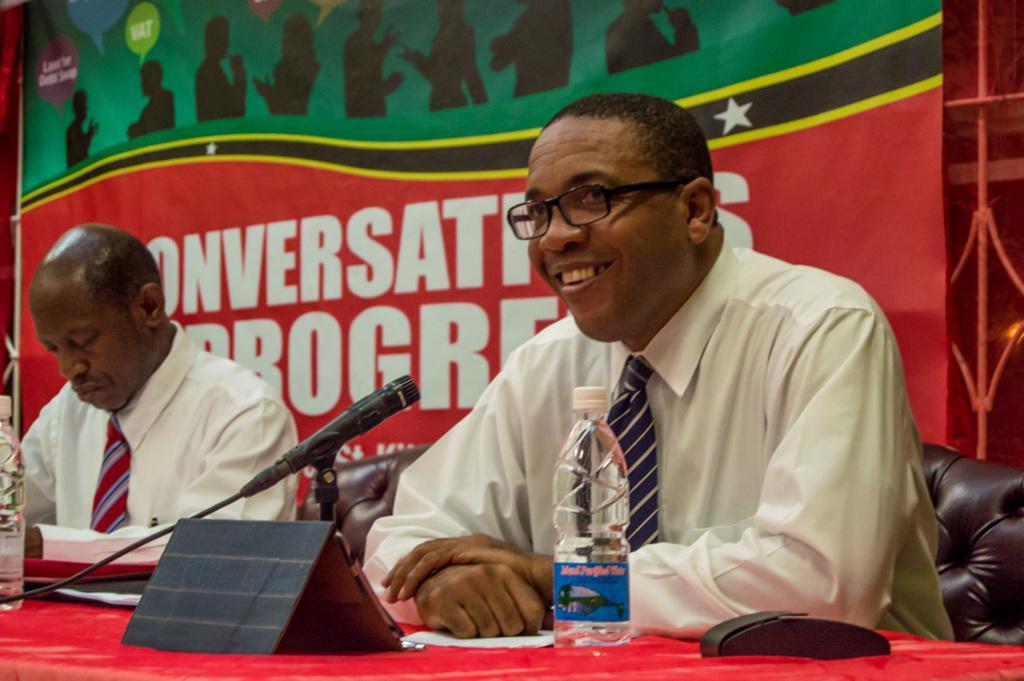Could you give a brief overview of what you see in this image? In this image we can see there are two people sitting on the chair, in front of the chair there is the table, on the table, we can see there are bottles, board, mic, papers and black color object. And at the back we can see the banner with text and images and there is the fence. 